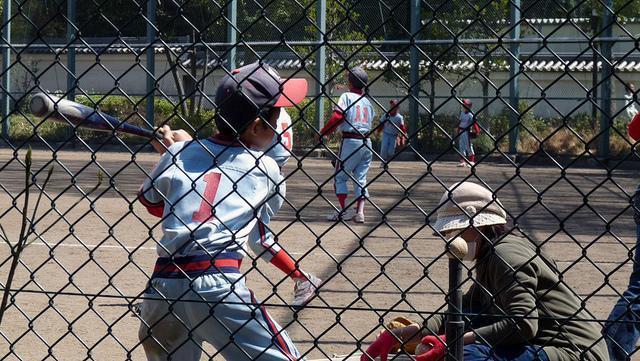How many people are in the photo?
Give a very brief answer. 5. 